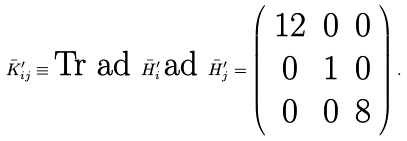<formula> <loc_0><loc_0><loc_500><loc_500>\bar { K } ^ { \prime } _ { i j } \equiv \text {Tr } \text {ad } \bar { H } ^ { \prime } _ { i } \, \text {ad } \bar { H } ^ { \prime } _ { j } = \left ( \begin{array} { c c c } 1 2 & 0 & 0 \\ 0 & 1 & 0 \\ 0 & 0 & 8 \\ \end{array} \right ) .</formula> 